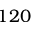<formula> <loc_0><loc_0><loc_500><loc_500>1 2 0</formula> 